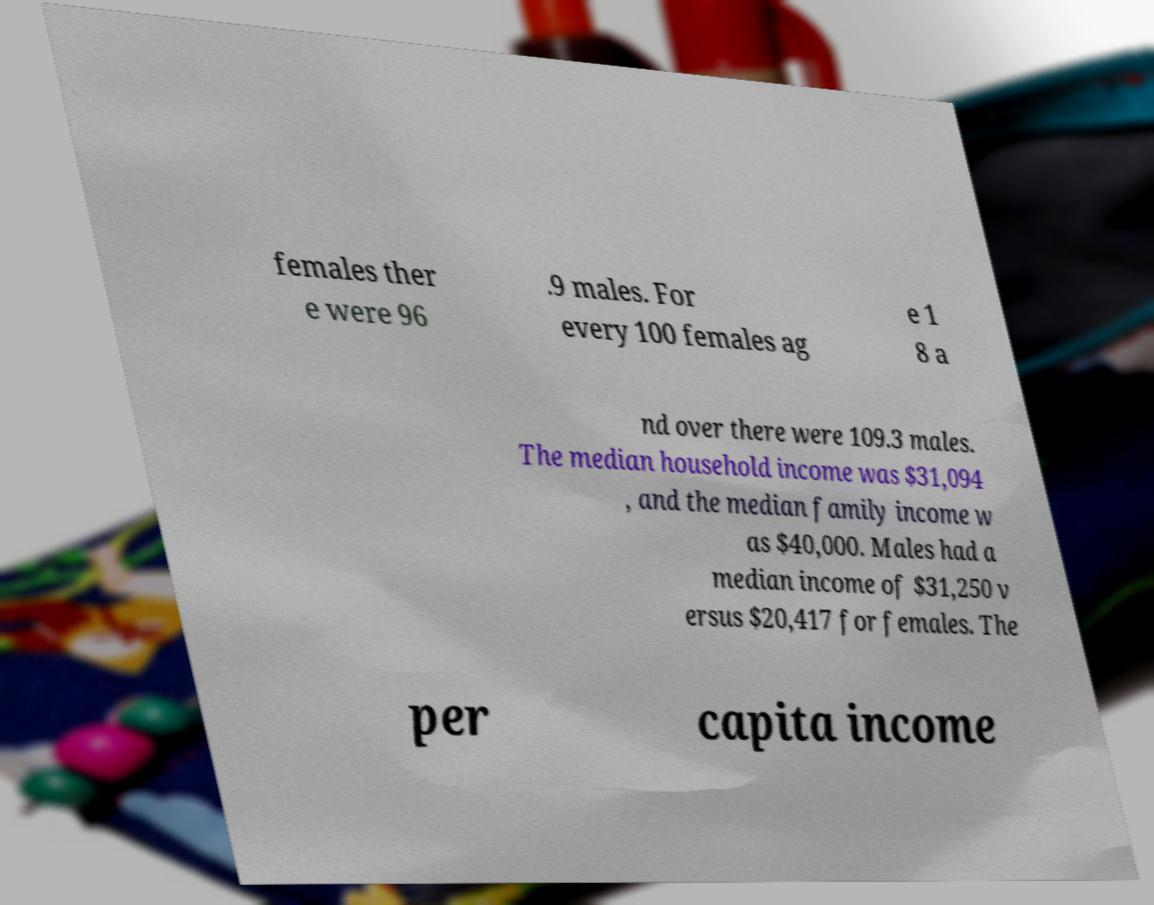Could you extract and type out the text from this image? females ther e were 96 .9 males. For every 100 females ag e 1 8 a nd over there were 109.3 males. The median household income was $31,094 , and the median family income w as $40,000. Males had a median income of $31,250 v ersus $20,417 for females. The per capita income 